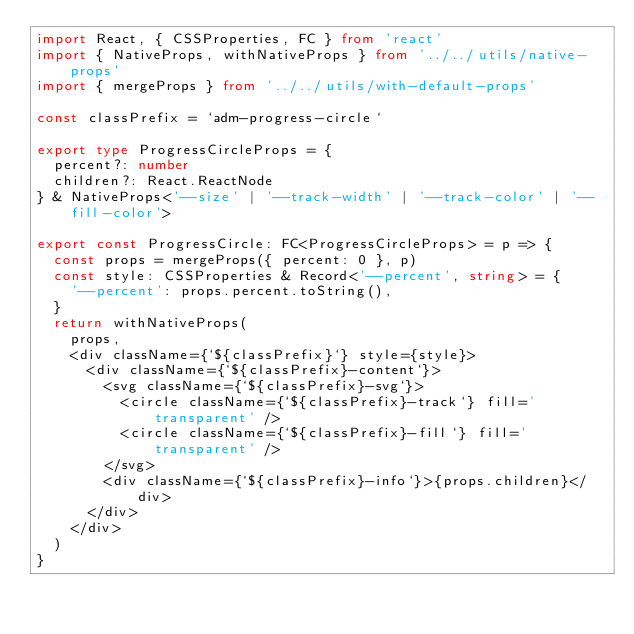<code> <loc_0><loc_0><loc_500><loc_500><_TypeScript_>import React, { CSSProperties, FC } from 'react'
import { NativeProps, withNativeProps } from '../../utils/native-props'
import { mergeProps } from '../../utils/with-default-props'

const classPrefix = `adm-progress-circle`

export type ProgressCircleProps = {
  percent?: number
  children?: React.ReactNode
} & NativeProps<'--size' | '--track-width' | '--track-color' | '--fill-color'>

export const ProgressCircle: FC<ProgressCircleProps> = p => {
  const props = mergeProps({ percent: 0 }, p)
  const style: CSSProperties & Record<'--percent', string> = {
    '--percent': props.percent.toString(),
  }
  return withNativeProps(
    props,
    <div className={`${classPrefix}`} style={style}>
      <div className={`${classPrefix}-content`}>
        <svg className={`${classPrefix}-svg`}>
          <circle className={`${classPrefix}-track`} fill='transparent' />
          <circle className={`${classPrefix}-fill`} fill='transparent' />
        </svg>
        <div className={`${classPrefix}-info`}>{props.children}</div>
      </div>
    </div>
  )
}
</code> 